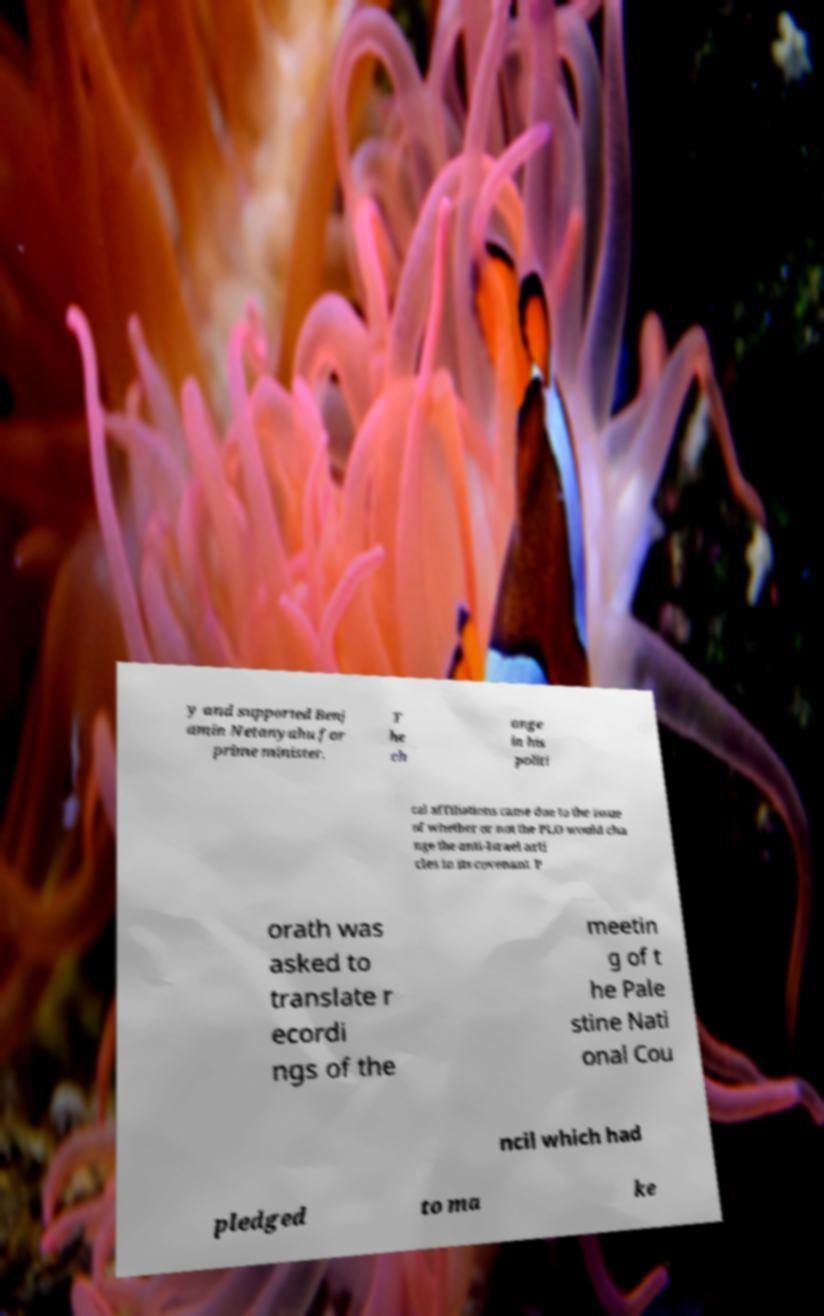I need the written content from this picture converted into text. Can you do that? y and supported Benj amin Netanyahu for prime minister. T he ch ange in his politi cal affiliations came due to the issue of whether or not the PLO would cha nge the anti-Israel arti cles in its covenant. P orath was asked to translate r ecordi ngs of the meetin g of t he Pale stine Nati onal Cou ncil which had pledged to ma ke 